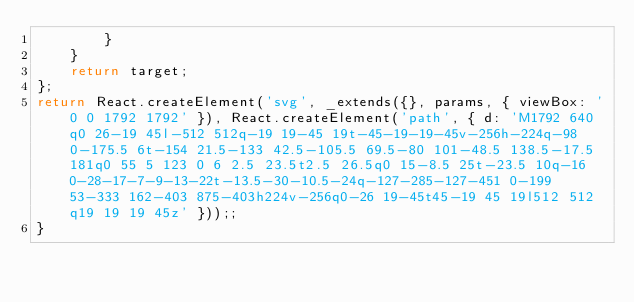<code> <loc_0><loc_0><loc_500><loc_500><_JavaScript_>        }
    }
    return target;
};
return React.createElement('svg', _extends({}, params, { viewBox: '0 0 1792 1792' }), React.createElement('path', { d: 'M1792 640q0 26-19 45l-512 512q-19 19-45 19t-45-19-19-45v-256h-224q-98 0-175.5 6t-154 21.5-133 42.5-105.5 69.5-80 101-48.5 138.5-17.5 181q0 55 5 123 0 6 2.5 23.5t2.5 26.5q0 15-8.5 25t-23.5 10q-16 0-28-17-7-9-13-22t-13.5-30-10.5-24q-127-285-127-451 0-199 53-333 162-403 875-403h224v-256q0-26 19-45t45-19 45 19l512 512q19 19 19 45z' }));;
}</code> 